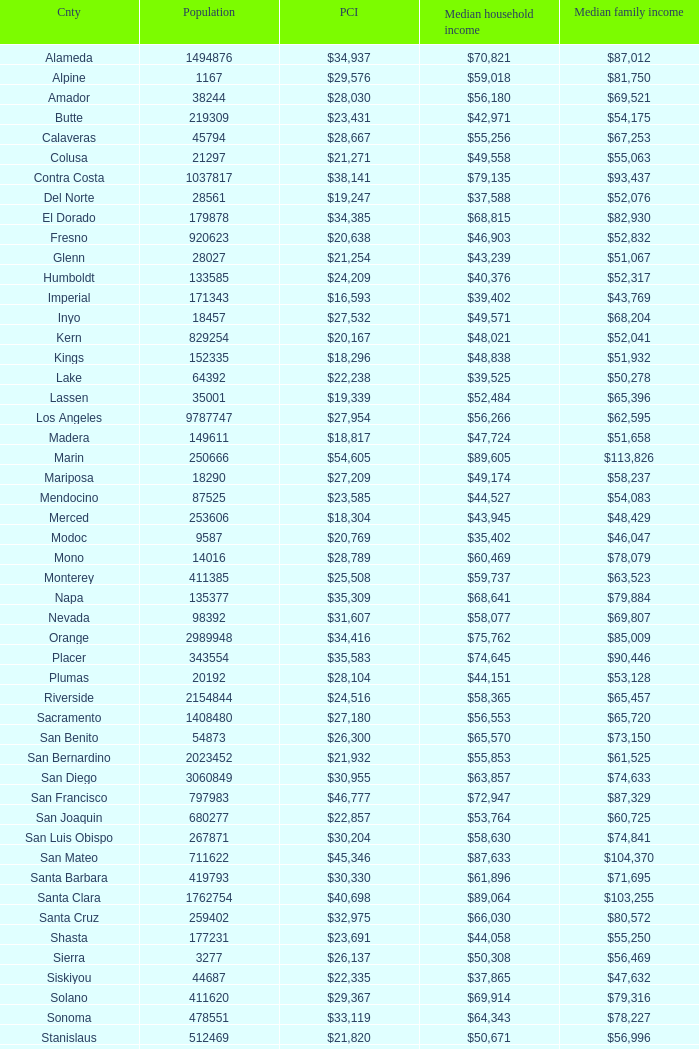What is the median household income of butte? $42,971. 